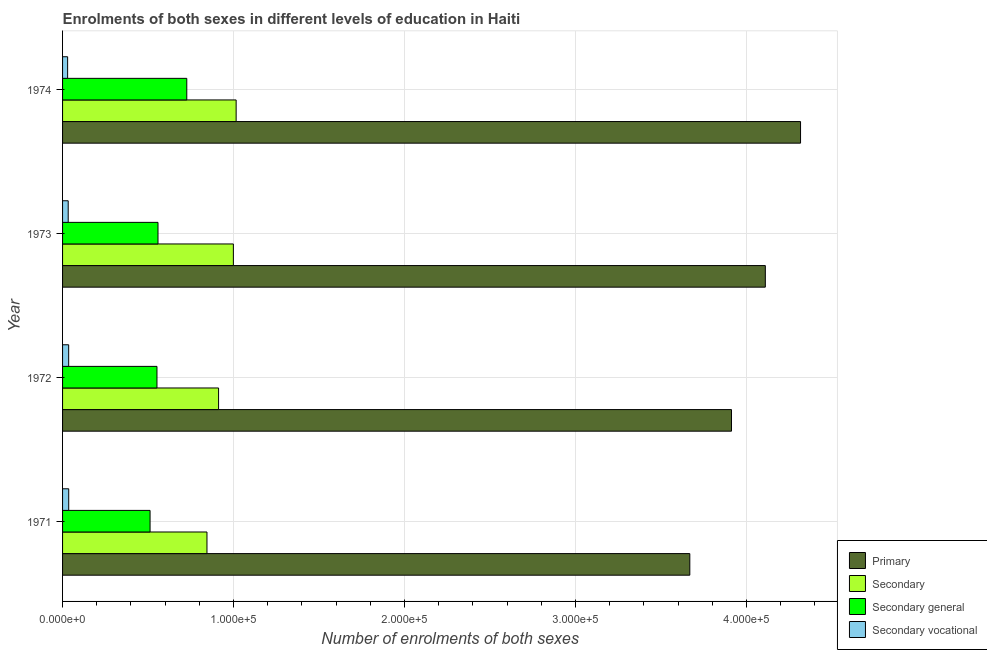How many groups of bars are there?
Make the answer very short. 4. Are the number of bars per tick equal to the number of legend labels?
Offer a terse response. Yes. Are the number of bars on each tick of the Y-axis equal?
Give a very brief answer. Yes. How many bars are there on the 3rd tick from the top?
Keep it short and to the point. 4. How many bars are there on the 1st tick from the bottom?
Make the answer very short. 4. What is the label of the 1st group of bars from the top?
Keep it short and to the point. 1974. What is the number of enrolments in secondary education in 1973?
Make the answer very short. 9.99e+04. Across all years, what is the maximum number of enrolments in primary education?
Offer a terse response. 4.32e+05. Across all years, what is the minimum number of enrolments in primary education?
Provide a succinct answer. 3.67e+05. In which year was the number of enrolments in primary education maximum?
Your answer should be compact. 1974. What is the total number of enrolments in secondary general education in the graph?
Offer a very short reply. 2.35e+05. What is the difference between the number of enrolments in primary education in 1971 and that in 1973?
Provide a succinct answer. -4.42e+04. What is the difference between the number of enrolments in secondary education in 1972 and the number of enrolments in primary education in 1974?
Your response must be concise. -3.40e+05. What is the average number of enrolments in secondary general education per year?
Offer a very short reply. 5.87e+04. In the year 1972, what is the difference between the number of enrolments in secondary general education and number of enrolments in primary education?
Your answer should be compact. -3.36e+05. What is the ratio of the number of enrolments in secondary vocational education in 1971 to that in 1973?
Provide a succinct answer. 1.09. What is the difference between the highest and the second highest number of enrolments in primary education?
Provide a succinct answer. 2.06e+04. What is the difference between the highest and the lowest number of enrolments in secondary vocational education?
Your response must be concise. 637. Is the sum of the number of enrolments in secondary vocational education in 1971 and 1974 greater than the maximum number of enrolments in secondary general education across all years?
Your response must be concise. No. What does the 1st bar from the top in 1973 represents?
Make the answer very short. Secondary vocational. What does the 4th bar from the bottom in 1971 represents?
Provide a short and direct response. Secondary vocational. Is it the case that in every year, the sum of the number of enrolments in primary education and number of enrolments in secondary education is greater than the number of enrolments in secondary general education?
Your answer should be compact. Yes. How many bars are there?
Your response must be concise. 16. Are all the bars in the graph horizontal?
Offer a very short reply. Yes. How many years are there in the graph?
Ensure brevity in your answer.  4. Does the graph contain any zero values?
Your response must be concise. No. Where does the legend appear in the graph?
Make the answer very short. Bottom right. How are the legend labels stacked?
Make the answer very short. Vertical. What is the title of the graph?
Keep it short and to the point. Enrolments of both sexes in different levels of education in Haiti. What is the label or title of the X-axis?
Your response must be concise. Number of enrolments of both sexes. What is the label or title of the Y-axis?
Keep it short and to the point. Year. What is the Number of enrolments of both sexes of Primary in 1971?
Provide a succinct answer. 3.67e+05. What is the Number of enrolments of both sexes of Secondary in 1971?
Offer a very short reply. 8.45e+04. What is the Number of enrolments of both sexes in Secondary general in 1971?
Keep it short and to the point. 5.12e+04. What is the Number of enrolments of both sexes of Secondary vocational in 1971?
Your response must be concise. 3594. What is the Number of enrolments of both sexes of Primary in 1972?
Your answer should be compact. 3.91e+05. What is the Number of enrolments of both sexes in Secondary in 1972?
Make the answer very short. 9.12e+04. What is the Number of enrolments of both sexes in Secondary general in 1972?
Your answer should be compact. 5.52e+04. What is the Number of enrolments of both sexes of Secondary vocational in 1972?
Keep it short and to the point. 3567. What is the Number of enrolments of both sexes in Primary in 1973?
Your answer should be compact. 4.11e+05. What is the Number of enrolments of both sexes of Secondary in 1973?
Ensure brevity in your answer.  9.99e+04. What is the Number of enrolments of both sexes of Secondary general in 1973?
Your answer should be compact. 5.58e+04. What is the Number of enrolments of both sexes in Secondary vocational in 1973?
Make the answer very short. 3298. What is the Number of enrolments of both sexes in Primary in 1974?
Ensure brevity in your answer.  4.32e+05. What is the Number of enrolments of both sexes of Secondary in 1974?
Give a very brief answer. 1.02e+05. What is the Number of enrolments of both sexes in Secondary general in 1974?
Your response must be concise. 7.27e+04. What is the Number of enrolments of both sexes of Secondary vocational in 1974?
Make the answer very short. 2957. Across all years, what is the maximum Number of enrolments of both sexes of Primary?
Your answer should be very brief. 4.32e+05. Across all years, what is the maximum Number of enrolments of both sexes in Secondary?
Ensure brevity in your answer.  1.02e+05. Across all years, what is the maximum Number of enrolments of both sexes of Secondary general?
Your answer should be compact. 7.27e+04. Across all years, what is the maximum Number of enrolments of both sexes in Secondary vocational?
Offer a very short reply. 3594. Across all years, what is the minimum Number of enrolments of both sexes in Primary?
Keep it short and to the point. 3.67e+05. Across all years, what is the minimum Number of enrolments of both sexes of Secondary?
Your answer should be very brief. 8.45e+04. Across all years, what is the minimum Number of enrolments of both sexes in Secondary general?
Keep it short and to the point. 5.12e+04. Across all years, what is the minimum Number of enrolments of both sexes in Secondary vocational?
Give a very brief answer. 2957. What is the total Number of enrolments of both sexes in Primary in the graph?
Make the answer very short. 1.60e+06. What is the total Number of enrolments of both sexes in Secondary in the graph?
Make the answer very short. 3.77e+05. What is the total Number of enrolments of both sexes in Secondary general in the graph?
Your response must be concise. 2.35e+05. What is the total Number of enrolments of both sexes of Secondary vocational in the graph?
Your answer should be very brief. 1.34e+04. What is the difference between the Number of enrolments of both sexes of Primary in 1971 and that in 1972?
Provide a short and direct response. -2.44e+04. What is the difference between the Number of enrolments of both sexes of Secondary in 1971 and that in 1972?
Offer a very short reply. -6793. What is the difference between the Number of enrolments of both sexes in Secondary general in 1971 and that in 1972?
Offer a terse response. -4039. What is the difference between the Number of enrolments of both sexes in Secondary vocational in 1971 and that in 1972?
Provide a succinct answer. 27. What is the difference between the Number of enrolments of both sexes in Primary in 1971 and that in 1973?
Provide a succinct answer. -4.42e+04. What is the difference between the Number of enrolments of both sexes in Secondary in 1971 and that in 1973?
Make the answer very short. -1.54e+04. What is the difference between the Number of enrolments of both sexes of Secondary general in 1971 and that in 1973?
Make the answer very short. -4642. What is the difference between the Number of enrolments of both sexes of Secondary vocational in 1971 and that in 1973?
Provide a succinct answer. 296. What is the difference between the Number of enrolments of both sexes in Primary in 1971 and that in 1974?
Your answer should be very brief. -6.48e+04. What is the difference between the Number of enrolments of both sexes of Secondary in 1971 and that in 1974?
Your answer should be compact. -1.71e+04. What is the difference between the Number of enrolments of both sexes in Secondary general in 1971 and that in 1974?
Provide a short and direct response. -2.15e+04. What is the difference between the Number of enrolments of both sexes of Secondary vocational in 1971 and that in 1974?
Your answer should be very brief. 637. What is the difference between the Number of enrolments of both sexes of Primary in 1972 and that in 1973?
Your answer should be compact. -1.98e+04. What is the difference between the Number of enrolments of both sexes of Secondary in 1972 and that in 1973?
Offer a terse response. -8647. What is the difference between the Number of enrolments of both sexes of Secondary general in 1972 and that in 1973?
Keep it short and to the point. -603. What is the difference between the Number of enrolments of both sexes of Secondary vocational in 1972 and that in 1973?
Give a very brief answer. 269. What is the difference between the Number of enrolments of both sexes of Primary in 1972 and that in 1974?
Offer a terse response. -4.04e+04. What is the difference between the Number of enrolments of both sexes of Secondary in 1972 and that in 1974?
Your response must be concise. -1.03e+04. What is the difference between the Number of enrolments of both sexes in Secondary general in 1972 and that in 1974?
Make the answer very short. -1.74e+04. What is the difference between the Number of enrolments of both sexes of Secondary vocational in 1972 and that in 1974?
Provide a succinct answer. 610. What is the difference between the Number of enrolments of both sexes of Primary in 1973 and that in 1974?
Offer a terse response. -2.06e+04. What is the difference between the Number of enrolments of both sexes of Secondary in 1973 and that in 1974?
Ensure brevity in your answer.  -1625. What is the difference between the Number of enrolments of both sexes of Secondary general in 1973 and that in 1974?
Your response must be concise. -1.68e+04. What is the difference between the Number of enrolments of both sexes of Secondary vocational in 1973 and that in 1974?
Offer a terse response. 341. What is the difference between the Number of enrolments of both sexes in Primary in 1971 and the Number of enrolments of both sexes in Secondary in 1972?
Make the answer very short. 2.76e+05. What is the difference between the Number of enrolments of both sexes in Primary in 1971 and the Number of enrolments of both sexes in Secondary general in 1972?
Keep it short and to the point. 3.12e+05. What is the difference between the Number of enrolments of both sexes of Primary in 1971 and the Number of enrolments of both sexes of Secondary vocational in 1972?
Your answer should be very brief. 3.63e+05. What is the difference between the Number of enrolments of both sexes of Secondary in 1971 and the Number of enrolments of both sexes of Secondary general in 1972?
Offer a very short reply. 2.92e+04. What is the difference between the Number of enrolments of both sexes in Secondary in 1971 and the Number of enrolments of both sexes in Secondary vocational in 1972?
Offer a terse response. 8.09e+04. What is the difference between the Number of enrolments of both sexes in Secondary general in 1971 and the Number of enrolments of both sexes in Secondary vocational in 1972?
Give a very brief answer. 4.76e+04. What is the difference between the Number of enrolments of both sexes of Primary in 1971 and the Number of enrolments of both sexes of Secondary in 1973?
Ensure brevity in your answer.  2.67e+05. What is the difference between the Number of enrolments of both sexes of Primary in 1971 and the Number of enrolments of both sexes of Secondary general in 1973?
Your answer should be very brief. 3.11e+05. What is the difference between the Number of enrolments of both sexes of Primary in 1971 and the Number of enrolments of both sexes of Secondary vocational in 1973?
Offer a very short reply. 3.64e+05. What is the difference between the Number of enrolments of both sexes in Secondary in 1971 and the Number of enrolments of both sexes in Secondary general in 1973?
Your answer should be compact. 2.86e+04. What is the difference between the Number of enrolments of both sexes in Secondary in 1971 and the Number of enrolments of both sexes in Secondary vocational in 1973?
Offer a terse response. 8.12e+04. What is the difference between the Number of enrolments of both sexes in Secondary general in 1971 and the Number of enrolments of both sexes in Secondary vocational in 1973?
Provide a short and direct response. 4.79e+04. What is the difference between the Number of enrolments of both sexes of Primary in 1971 and the Number of enrolments of both sexes of Secondary in 1974?
Your answer should be compact. 2.65e+05. What is the difference between the Number of enrolments of both sexes of Primary in 1971 and the Number of enrolments of both sexes of Secondary general in 1974?
Keep it short and to the point. 2.94e+05. What is the difference between the Number of enrolments of both sexes in Primary in 1971 and the Number of enrolments of both sexes in Secondary vocational in 1974?
Give a very brief answer. 3.64e+05. What is the difference between the Number of enrolments of both sexes of Secondary in 1971 and the Number of enrolments of both sexes of Secondary general in 1974?
Offer a very short reply. 1.18e+04. What is the difference between the Number of enrolments of both sexes of Secondary in 1971 and the Number of enrolments of both sexes of Secondary vocational in 1974?
Offer a terse response. 8.15e+04. What is the difference between the Number of enrolments of both sexes of Secondary general in 1971 and the Number of enrolments of both sexes of Secondary vocational in 1974?
Give a very brief answer. 4.82e+04. What is the difference between the Number of enrolments of both sexes in Primary in 1972 and the Number of enrolments of both sexes in Secondary in 1973?
Provide a succinct answer. 2.91e+05. What is the difference between the Number of enrolments of both sexes in Primary in 1972 and the Number of enrolments of both sexes in Secondary general in 1973?
Provide a short and direct response. 3.35e+05. What is the difference between the Number of enrolments of both sexes of Primary in 1972 and the Number of enrolments of both sexes of Secondary vocational in 1973?
Provide a short and direct response. 3.88e+05. What is the difference between the Number of enrolments of both sexes in Secondary in 1972 and the Number of enrolments of both sexes in Secondary general in 1973?
Give a very brief answer. 3.54e+04. What is the difference between the Number of enrolments of both sexes of Secondary in 1972 and the Number of enrolments of both sexes of Secondary vocational in 1973?
Offer a very short reply. 8.79e+04. What is the difference between the Number of enrolments of both sexes in Secondary general in 1972 and the Number of enrolments of both sexes in Secondary vocational in 1973?
Offer a very short reply. 5.19e+04. What is the difference between the Number of enrolments of both sexes of Primary in 1972 and the Number of enrolments of both sexes of Secondary in 1974?
Keep it short and to the point. 2.90e+05. What is the difference between the Number of enrolments of both sexes of Primary in 1972 and the Number of enrolments of both sexes of Secondary general in 1974?
Your answer should be very brief. 3.19e+05. What is the difference between the Number of enrolments of both sexes of Primary in 1972 and the Number of enrolments of both sexes of Secondary vocational in 1974?
Offer a terse response. 3.88e+05. What is the difference between the Number of enrolments of both sexes of Secondary in 1972 and the Number of enrolments of both sexes of Secondary general in 1974?
Offer a terse response. 1.86e+04. What is the difference between the Number of enrolments of both sexes of Secondary in 1972 and the Number of enrolments of both sexes of Secondary vocational in 1974?
Ensure brevity in your answer.  8.83e+04. What is the difference between the Number of enrolments of both sexes in Secondary general in 1972 and the Number of enrolments of both sexes in Secondary vocational in 1974?
Provide a succinct answer. 5.23e+04. What is the difference between the Number of enrolments of both sexes in Primary in 1973 and the Number of enrolments of both sexes in Secondary in 1974?
Your answer should be very brief. 3.09e+05. What is the difference between the Number of enrolments of both sexes in Primary in 1973 and the Number of enrolments of both sexes in Secondary general in 1974?
Provide a short and direct response. 3.38e+05. What is the difference between the Number of enrolments of both sexes in Primary in 1973 and the Number of enrolments of both sexes in Secondary vocational in 1974?
Provide a short and direct response. 4.08e+05. What is the difference between the Number of enrolments of both sexes in Secondary in 1973 and the Number of enrolments of both sexes in Secondary general in 1974?
Offer a very short reply. 2.72e+04. What is the difference between the Number of enrolments of both sexes in Secondary in 1973 and the Number of enrolments of both sexes in Secondary vocational in 1974?
Give a very brief answer. 9.69e+04. What is the difference between the Number of enrolments of both sexes in Secondary general in 1973 and the Number of enrolments of both sexes in Secondary vocational in 1974?
Your answer should be very brief. 5.29e+04. What is the average Number of enrolments of both sexes in Primary per year?
Provide a short and direct response. 4.00e+05. What is the average Number of enrolments of both sexes of Secondary per year?
Your answer should be compact. 9.43e+04. What is the average Number of enrolments of both sexes of Secondary general per year?
Offer a very short reply. 5.87e+04. What is the average Number of enrolments of both sexes in Secondary vocational per year?
Your answer should be compact. 3354. In the year 1971, what is the difference between the Number of enrolments of both sexes in Primary and Number of enrolments of both sexes in Secondary?
Provide a succinct answer. 2.82e+05. In the year 1971, what is the difference between the Number of enrolments of both sexes in Primary and Number of enrolments of both sexes in Secondary general?
Keep it short and to the point. 3.16e+05. In the year 1971, what is the difference between the Number of enrolments of both sexes of Primary and Number of enrolments of both sexes of Secondary vocational?
Give a very brief answer. 3.63e+05. In the year 1971, what is the difference between the Number of enrolments of both sexes of Secondary and Number of enrolments of both sexes of Secondary general?
Your response must be concise. 3.33e+04. In the year 1971, what is the difference between the Number of enrolments of both sexes in Secondary and Number of enrolments of both sexes in Secondary vocational?
Provide a succinct answer. 8.09e+04. In the year 1971, what is the difference between the Number of enrolments of both sexes of Secondary general and Number of enrolments of both sexes of Secondary vocational?
Ensure brevity in your answer.  4.76e+04. In the year 1972, what is the difference between the Number of enrolments of both sexes in Primary and Number of enrolments of both sexes in Secondary?
Keep it short and to the point. 3.00e+05. In the year 1972, what is the difference between the Number of enrolments of both sexes in Primary and Number of enrolments of both sexes in Secondary general?
Give a very brief answer. 3.36e+05. In the year 1972, what is the difference between the Number of enrolments of both sexes of Primary and Number of enrolments of both sexes of Secondary vocational?
Provide a succinct answer. 3.88e+05. In the year 1972, what is the difference between the Number of enrolments of both sexes of Secondary and Number of enrolments of both sexes of Secondary general?
Offer a very short reply. 3.60e+04. In the year 1972, what is the difference between the Number of enrolments of both sexes of Secondary and Number of enrolments of both sexes of Secondary vocational?
Make the answer very short. 8.77e+04. In the year 1972, what is the difference between the Number of enrolments of both sexes of Secondary general and Number of enrolments of both sexes of Secondary vocational?
Ensure brevity in your answer.  5.16e+04. In the year 1973, what is the difference between the Number of enrolments of both sexes of Primary and Number of enrolments of both sexes of Secondary?
Provide a short and direct response. 3.11e+05. In the year 1973, what is the difference between the Number of enrolments of both sexes of Primary and Number of enrolments of both sexes of Secondary general?
Provide a succinct answer. 3.55e+05. In the year 1973, what is the difference between the Number of enrolments of both sexes in Primary and Number of enrolments of both sexes in Secondary vocational?
Your answer should be compact. 4.08e+05. In the year 1973, what is the difference between the Number of enrolments of both sexes in Secondary and Number of enrolments of both sexes in Secondary general?
Your answer should be compact. 4.41e+04. In the year 1973, what is the difference between the Number of enrolments of both sexes in Secondary and Number of enrolments of both sexes in Secondary vocational?
Offer a terse response. 9.66e+04. In the year 1973, what is the difference between the Number of enrolments of both sexes of Secondary general and Number of enrolments of both sexes of Secondary vocational?
Offer a very short reply. 5.25e+04. In the year 1974, what is the difference between the Number of enrolments of both sexes in Primary and Number of enrolments of both sexes in Secondary?
Offer a terse response. 3.30e+05. In the year 1974, what is the difference between the Number of enrolments of both sexes in Primary and Number of enrolments of both sexes in Secondary general?
Offer a terse response. 3.59e+05. In the year 1974, what is the difference between the Number of enrolments of both sexes of Primary and Number of enrolments of both sexes of Secondary vocational?
Your answer should be very brief. 4.29e+05. In the year 1974, what is the difference between the Number of enrolments of both sexes in Secondary and Number of enrolments of both sexes in Secondary general?
Your answer should be compact. 2.89e+04. In the year 1974, what is the difference between the Number of enrolments of both sexes in Secondary and Number of enrolments of both sexes in Secondary vocational?
Provide a short and direct response. 9.86e+04. In the year 1974, what is the difference between the Number of enrolments of both sexes in Secondary general and Number of enrolments of both sexes in Secondary vocational?
Your answer should be very brief. 6.97e+04. What is the ratio of the Number of enrolments of both sexes in Primary in 1971 to that in 1972?
Offer a very short reply. 0.94. What is the ratio of the Number of enrolments of both sexes in Secondary in 1971 to that in 1972?
Make the answer very short. 0.93. What is the ratio of the Number of enrolments of both sexes in Secondary general in 1971 to that in 1972?
Give a very brief answer. 0.93. What is the ratio of the Number of enrolments of both sexes in Secondary vocational in 1971 to that in 1972?
Provide a short and direct response. 1.01. What is the ratio of the Number of enrolments of both sexes in Primary in 1971 to that in 1973?
Keep it short and to the point. 0.89. What is the ratio of the Number of enrolments of both sexes in Secondary in 1971 to that in 1973?
Give a very brief answer. 0.85. What is the ratio of the Number of enrolments of both sexes in Secondary general in 1971 to that in 1973?
Your answer should be very brief. 0.92. What is the ratio of the Number of enrolments of both sexes in Secondary vocational in 1971 to that in 1973?
Your response must be concise. 1.09. What is the ratio of the Number of enrolments of both sexes in Secondary in 1971 to that in 1974?
Keep it short and to the point. 0.83. What is the ratio of the Number of enrolments of both sexes of Secondary general in 1971 to that in 1974?
Keep it short and to the point. 0.7. What is the ratio of the Number of enrolments of both sexes of Secondary vocational in 1971 to that in 1974?
Ensure brevity in your answer.  1.22. What is the ratio of the Number of enrolments of both sexes in Primary in 1972 to that in 1973?
Your answer should be very brief. 0.95. What is the ratio of the Number of enrolments of both sexes in Secondary in 1972 to that in 1973?
Provide a short and direct response. 0.91. What is the ratio of the Number of enrolments of both sexes in Secondary vocational in 1972 to that in 1973?
Provide a succinct answer. 1.08. What is the ratio of the Number of enrolments of both sexes in Primary in 1972 to that in 1974?
Offer a very short reply. 0.91. What is the ratio of the Number of enrolments of both sexes of Secondary in 1972 to that in 1974?
Give a very brief answer. 0.9. What is the ratio of the Number of enrolments of both sexes in Secondary general in 1972 to that in 1974?
Keep it short and to the point. 0.76. What is the ratio of the Number of enrolments of both sexes in Secondary vocational in 1972 to that in 1974?
Offer a terse response. 1.21. What is the ratio of the Number of enrolments of both sexes of Primary in 1973 to that in 1974?
Provide a short and direct response. 0.95. What is the ratio of the Number of enrolments of both sexes of Secondary general in 1973 to that in 1974?
Give a very brief answer. 0.77. What is the ratio of the Number of enrolments of both sexes of Secondary vocational in 1973 to that in 1974?
Provide a succinct answer. 1.12. What is the difference between the highest and the second highest Number of enrolments of both sexes of Primary?
Your answer should be compact. 2.06e+04. What is the difference between the highest and the second highest Number of enrolments of both sexes in Secondary?
Keep it short and to the point. 1625. What is the difference between the highest and the second highest Number of enrolments of both sexes of Secondary general?
Your response must be concise. 1.68e+04. What is the difference between the highest and the lowest Number of enrolments of both sexes in Primary?
Offer a very short reply. 6.48e+04. What is the difference between the highest and the lowest Number of enrolments of both sexes in Secondary?
Make the answer very short. 1.71e+04. What is the difference between the highest and the lowest Number of enrolments of both sexes in Secondary general?
Your answer should be compact. 2.15e+04. What is the difference between the highest and the lowest Number of enrolments of both sexes in Secondary vocational?
Your answer should be compact. 637. 